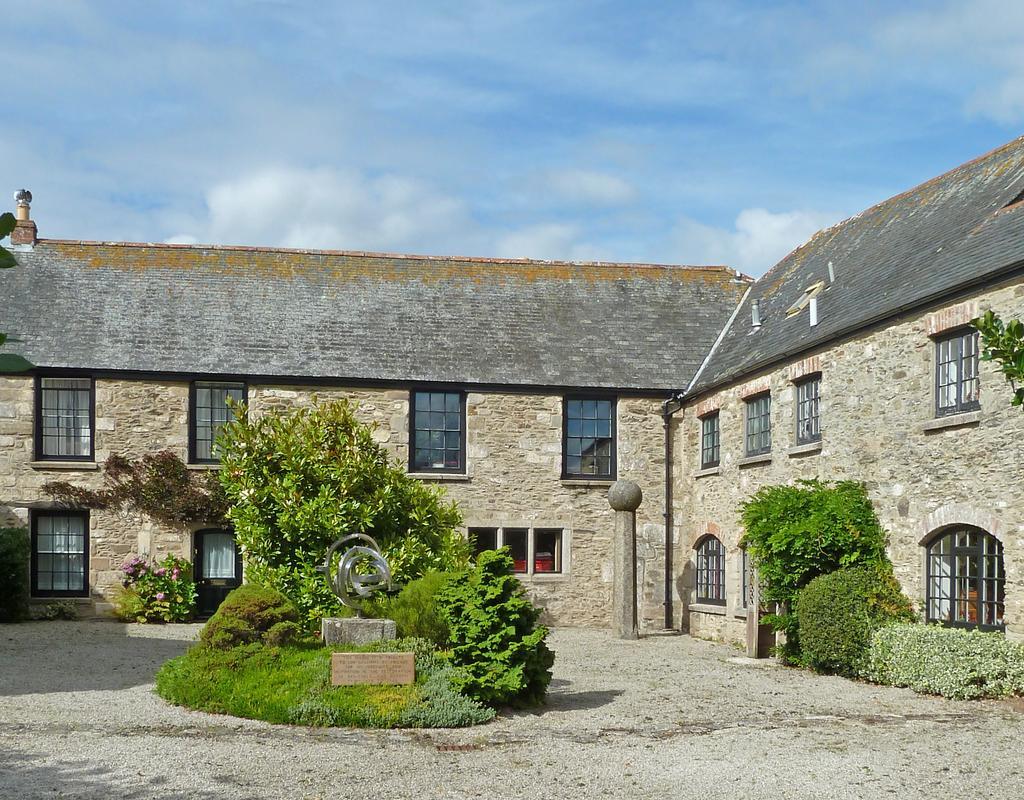In one or two sentences, can you explain what this image depicts? In this image, we can see two houses with glass windows. At the bottom, there is a ground, few plants, trees, some statue we can see here. Background we can see a pillar, wall and pole. Top of the image, there is a cloudy sky. 